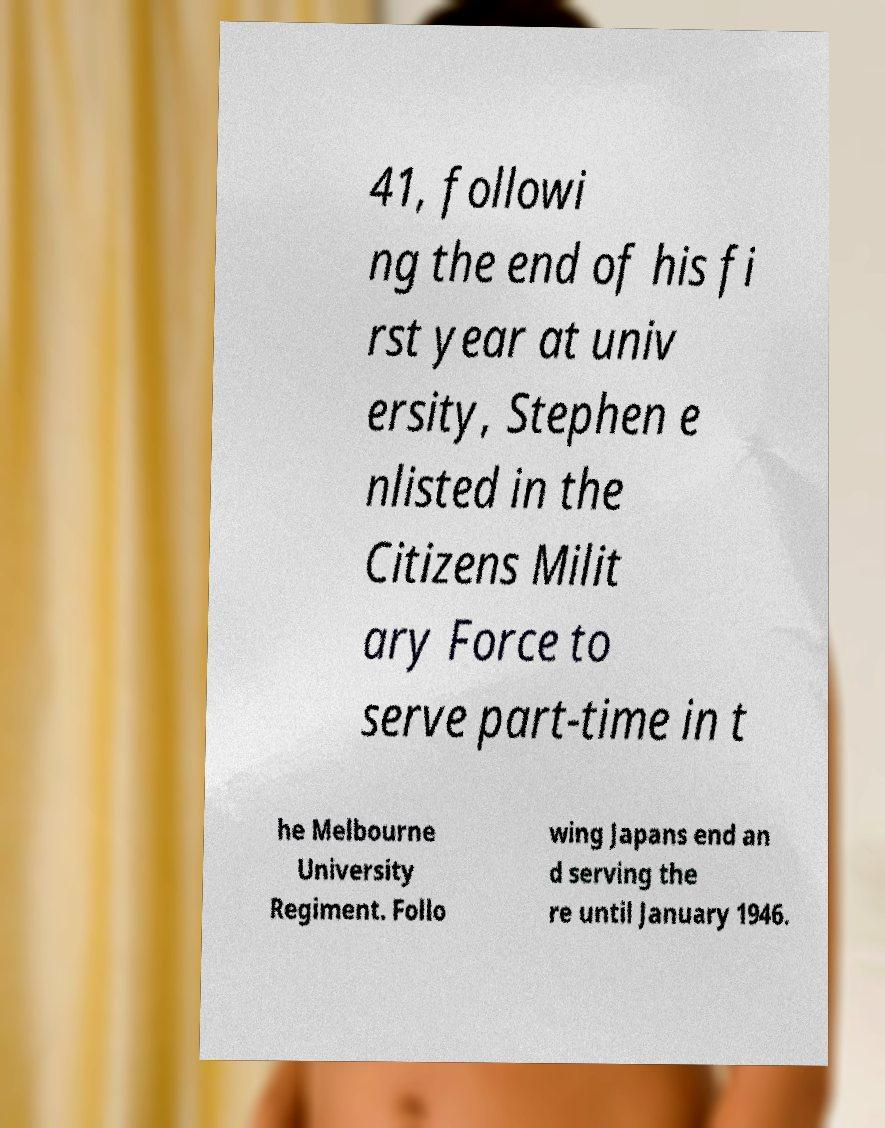What messages or text are displayed in this image? I need them in a readable, typed format. 41, followi ng the end of his fi rst year at univ ersity, Stephen e nlisted in the Citizens Milit ary Force to serve part-time in t he Melbourne University Regiment. Follo wing Japans end an d serving the re until January 1946. 